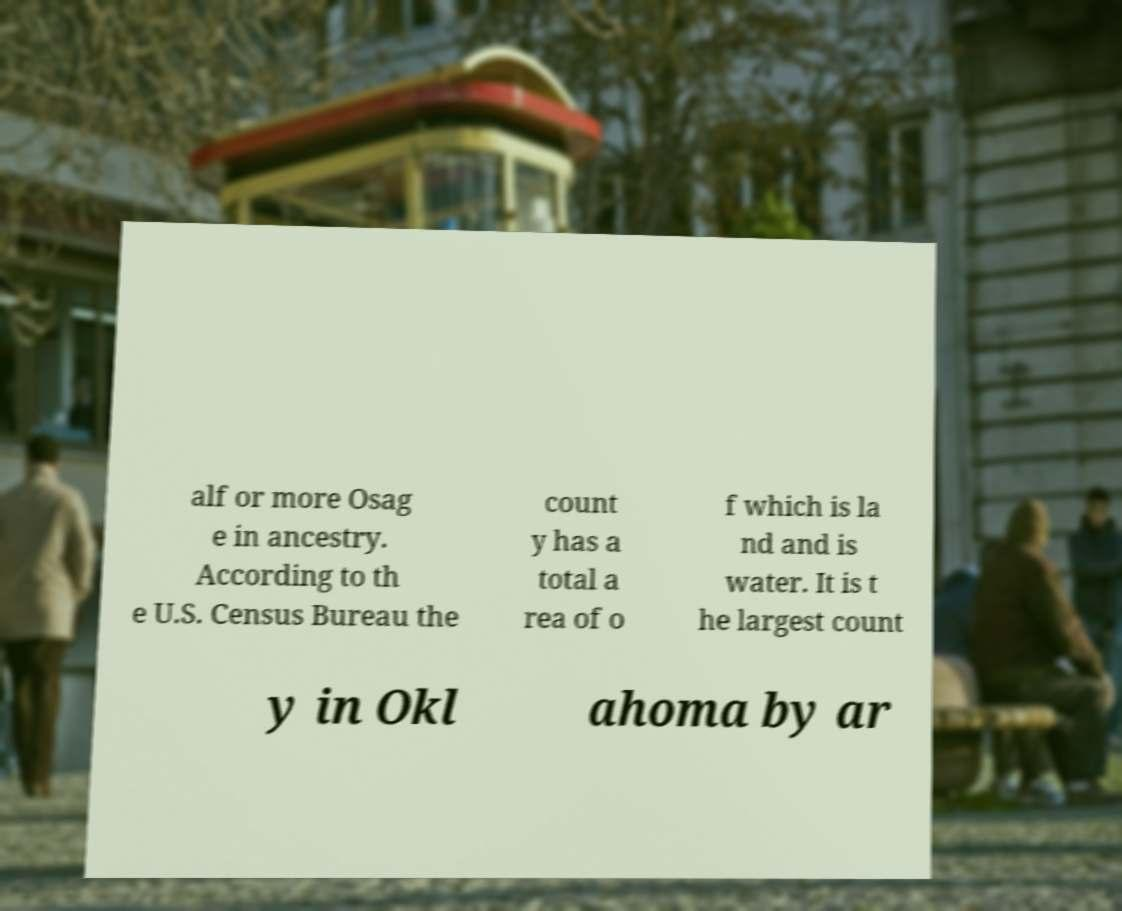Could you extract and type out the text from this image? alf or more Osag e in ancestry. According to th e U.S. Census Bureau the count y has a total a rea of o f which is la nd and is water. It is t he largest count y in Okl ahoma by ar 